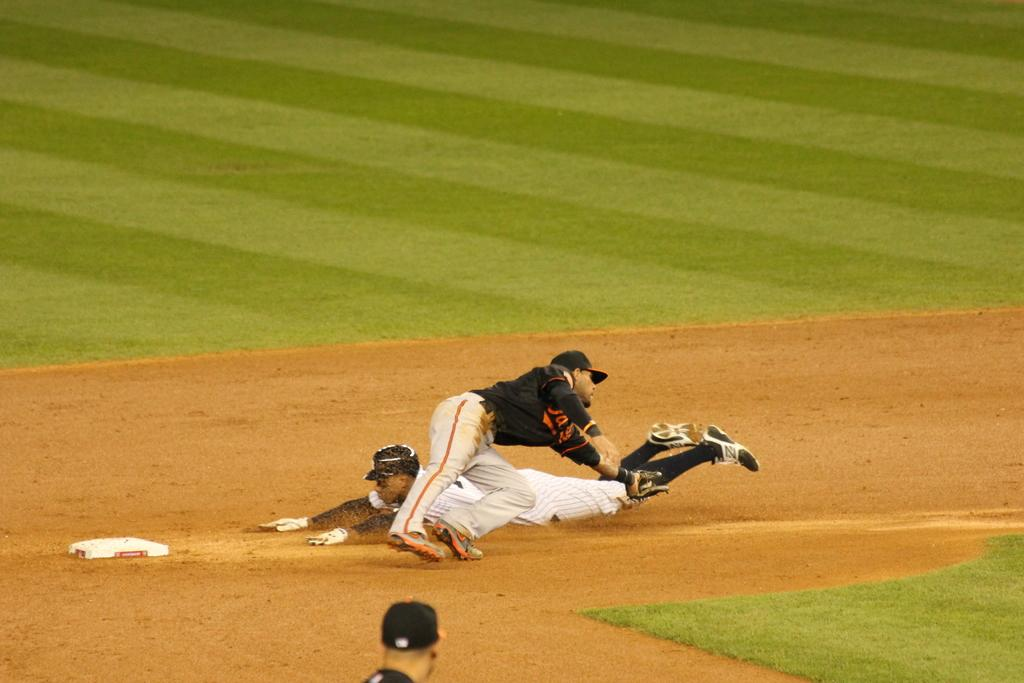Who or what can be seen in the image? There are people in the image. What is the white object on the ground? The white object on the ground is not specified in the facts provided. What type of terrain is visible in the image? Grass is present in the image. What flavor of toothpaste is being used by the people in the image? There is no toothpaste present in the image, so it cannot be determined what flavor might be used. 